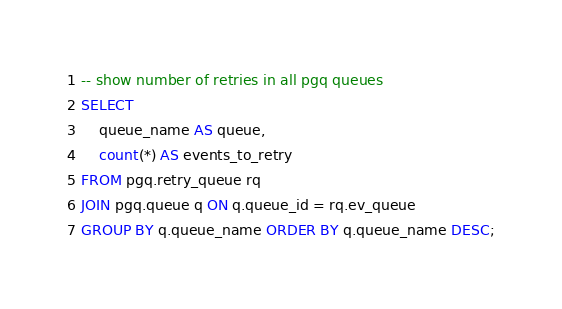Convert code to text. <code><loc_0><loc_0><loc_500><loc_500><_SQL_>-- show number of retries in all pgq queues
SELECT
    queue_name AS queue,
    count(*) AS events_to_retry
FROM pgq.retry_queue rq
JOIN pgq.queue q ON q.queue_id = rq.ev_queue
GROUP BY q.queue_name ORDER BY q.queue_name DESC;
</code> 